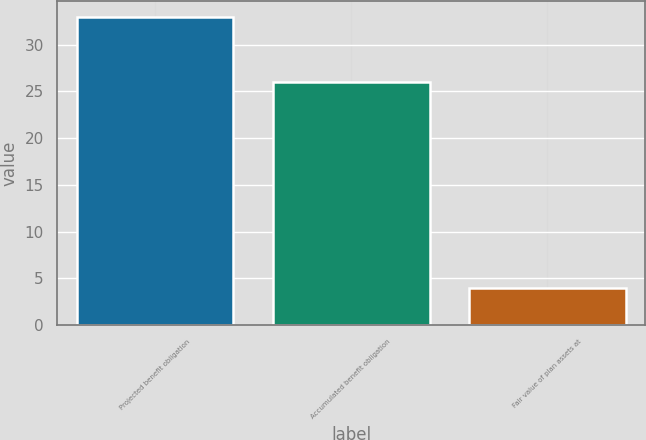Convert chart. <chart><loc_0><loc_0><loc_500><loc_500><bar_chart><fcel>Projected benefit obligation<fcel>Accumulated benefit obligation<fcel>Fair value of plan assets at<nl><fcel>33<fcel>26<fcel>4<nl></chart> 